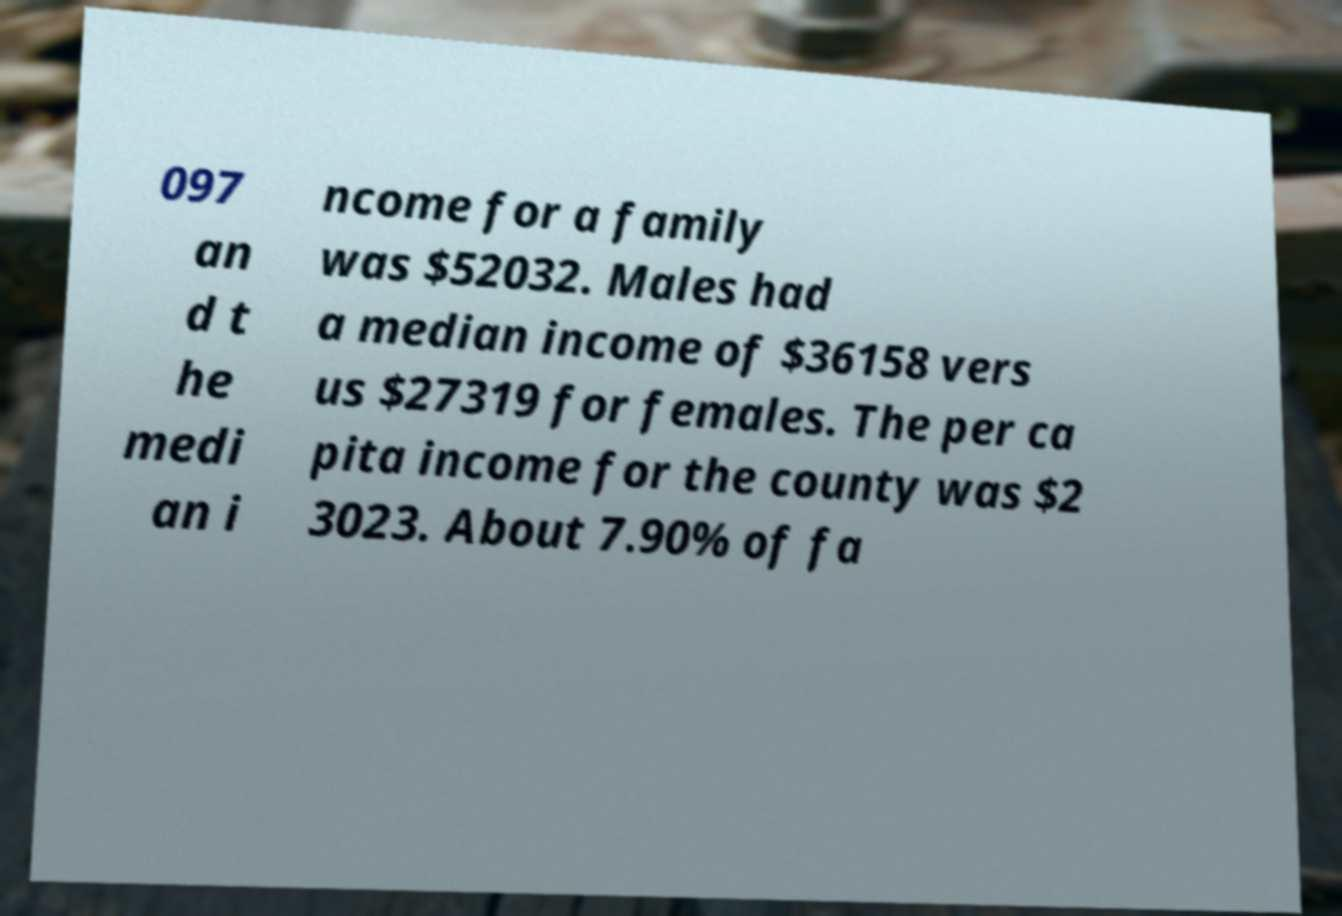There's text embedded in this image that I need extracted. Can you transcribe it verbatim? 097 an d t he medi an i ncome for a family was $52032. Males had a median income of $36158 vers us $27319 for females. The per ca pita income for the county was $2 3023. About 7.90% of fa 